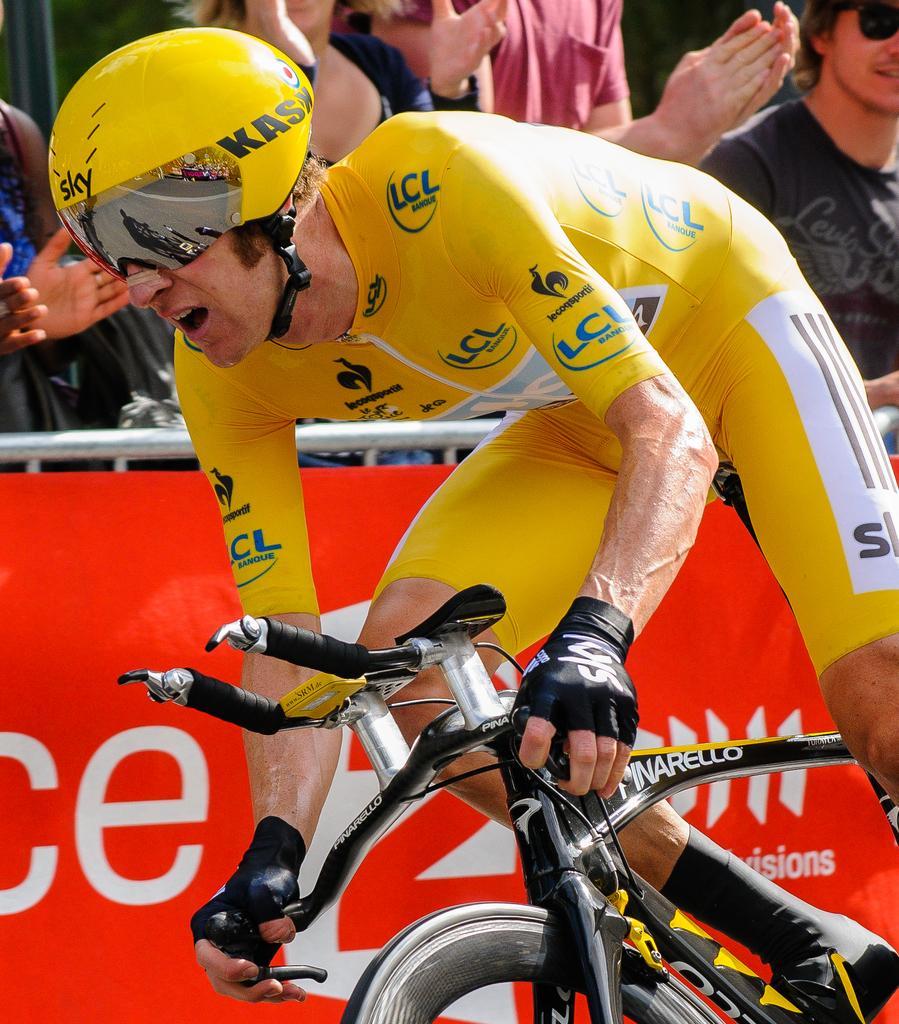Can you describe this image briefly? The man riding the bicycle is wearing yellow color t-shirt and short. He is even wearing helmet and gloves for his hands. Beside beside him, we find a red color board and behind this board, we find people clapping their hands which means encouraging the man riding bicycle. Next to them, we find a man on the right corner is wearing black color t-shirt and he is wearing goggles 